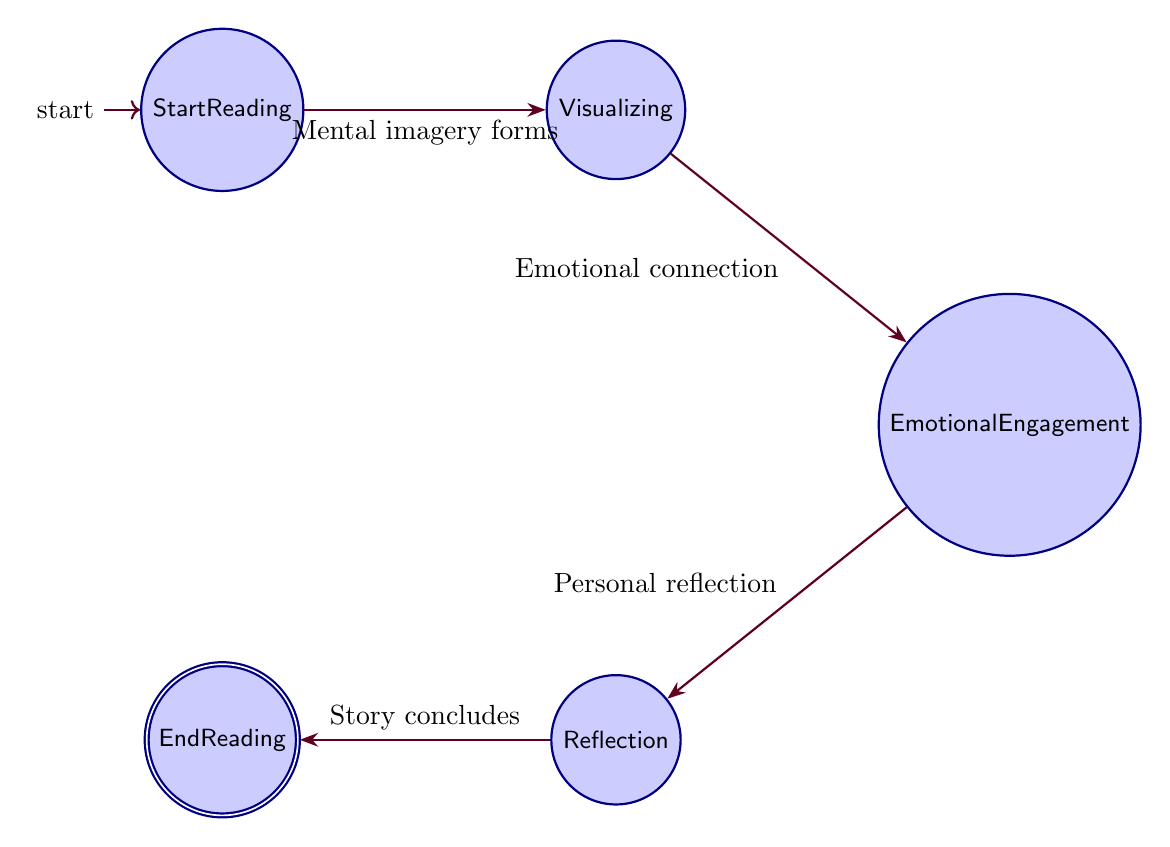What is the initial state in the diagram? The diagram starts with the "StartReading" node, which represents the initial state of the reader engaging with the narrative.
Answer: StartReading How many states are there in total? There are five states in the diagram: StartReading, Visualizing, Emotional Engagement, Reflection, and EndReading.
Answer: 5 What is the transition from "Visualizing" to "Emotional Engagement"? This transition is described as the reader forming emotional connections as a result of the vivid mental imagery created during the visualizing stage.
Answer: Emotional connection Which state comes before "Reflection"? The state that precedes "Reflection" is "Emotional Engagement," where the reader has become emotionally invested before reflecting on the narrative.
Answer: Emotional Engagement What is the final state in the diagram? The final state where the reader concludes their experience with the narrative is indicated as "EndReading."
Answer: EndReading What does the transition from "StartReading" to "Visualizing" signify? This transition signifies that as the reader begins to read the narrative, they start creating mental images based on what they are processing from the text.
Answer: Mental imagery forms Describe the relationship between "Emotional Engagement" and "Reflection". The relationship indicates that after developing an emotional connection with the story, the reader shifts to a reflective state, where they consider the narrative more personally.
Answer: Personal reflection How many transitions are depicted in the diagram? The diagram includes four transitions that illustrate the flow from one state to another as the reader progresses through their engagement with the narrative.
Answer: 4 What is the description of the transition from "Reflection" to "EndReading"? This transition describes the process where, after reflecting on the narrative, the reader reaches the conclusion of the story, marking their journey's end.
Answer: Story concludes 